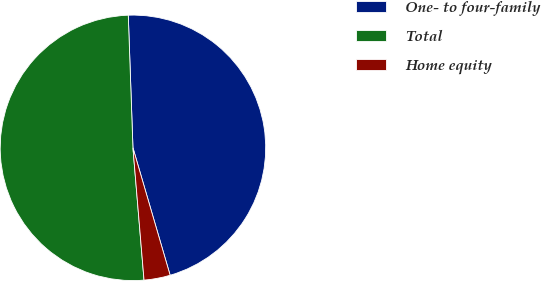Convert chart to OTSL. <chart><loc_0><loc_0><loc_500><loc_500><pie_chart><fcel>One- to four-family<fcel>Total<fcel>Home equity<nl><fcel>46.04%<fcel>50.77%<fcel>3.19%<nl></chart> 